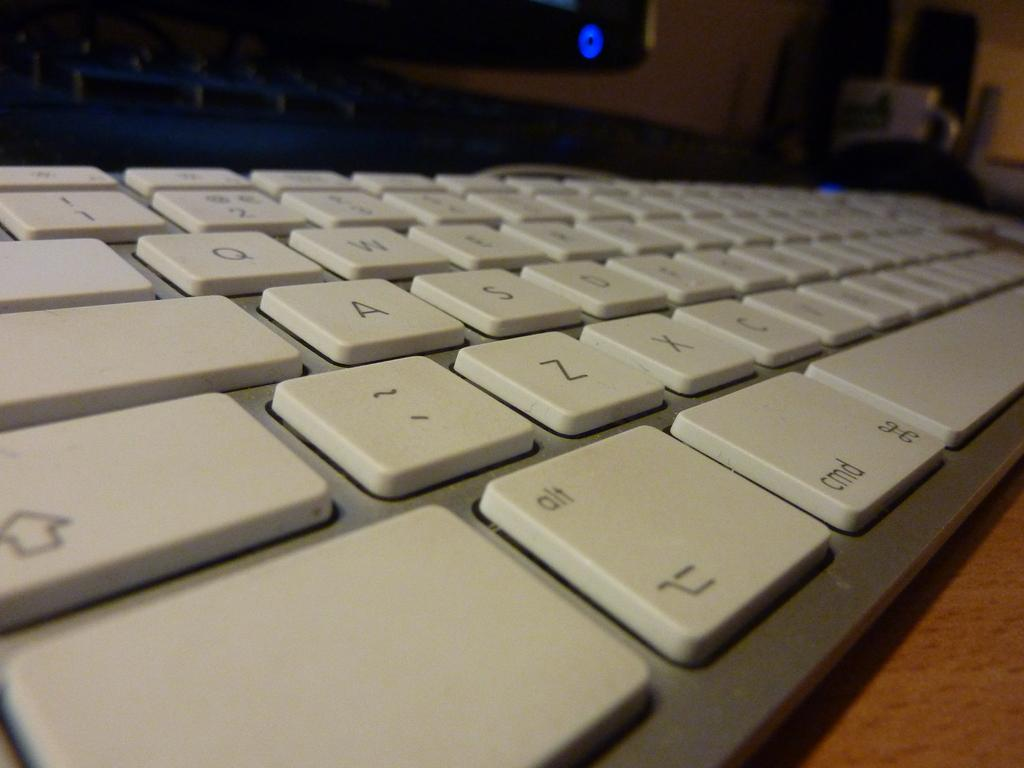<image>
Present a compact description of the photo's key features. A white QWERTY keyboard sitting on a table 